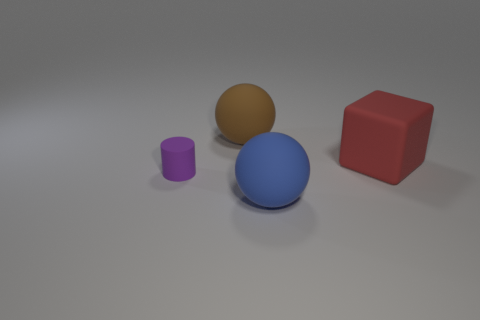Add 3 big blue matte things. How many objects exist? 7 Subtract all cylinders. How many objects are left? 3 Subtract all brown spheres. How many spheres are left? 1 Add 4 small purple objects. How many small purple objects are left? 5 Add 3 large yellow cylinders. How many large yellow cylinders exist? 3 Subtract 0 blue cylinders. How many objects are left? 4 Subtract all green balls. Subtract all gray cubes. How many balls are left? 2 Subtract all matte balls. Subtract all tiny purple objects. How many objects are left? 1 